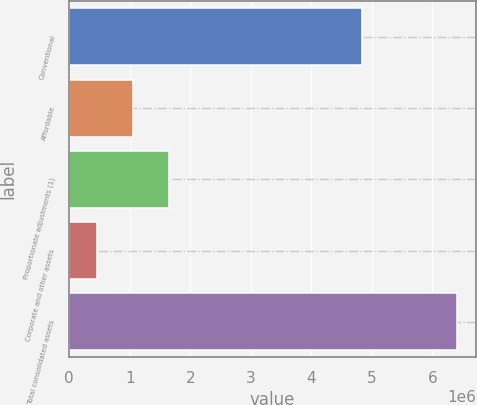<chart> <loc_0><loc_0><loc_500><loc_500><bar_chart><fcel>Conventional<fcel>Affordable<fcel>Proportionate adjustments (1)<fcel>Corporate and other assets<fcel>Total consolidated assets<nl><fcel>4.83724e+06<fcel>1.05649e+06<fcel>1.65036e+06<fcel>462608<fcel>6.40138e+06<nl></chart> 